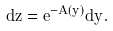Convert formula to latex. <formula><loc_0><loc_0><loc_500><loc_500>d z = e ^ { - A ( y ) } d y .</formula> 